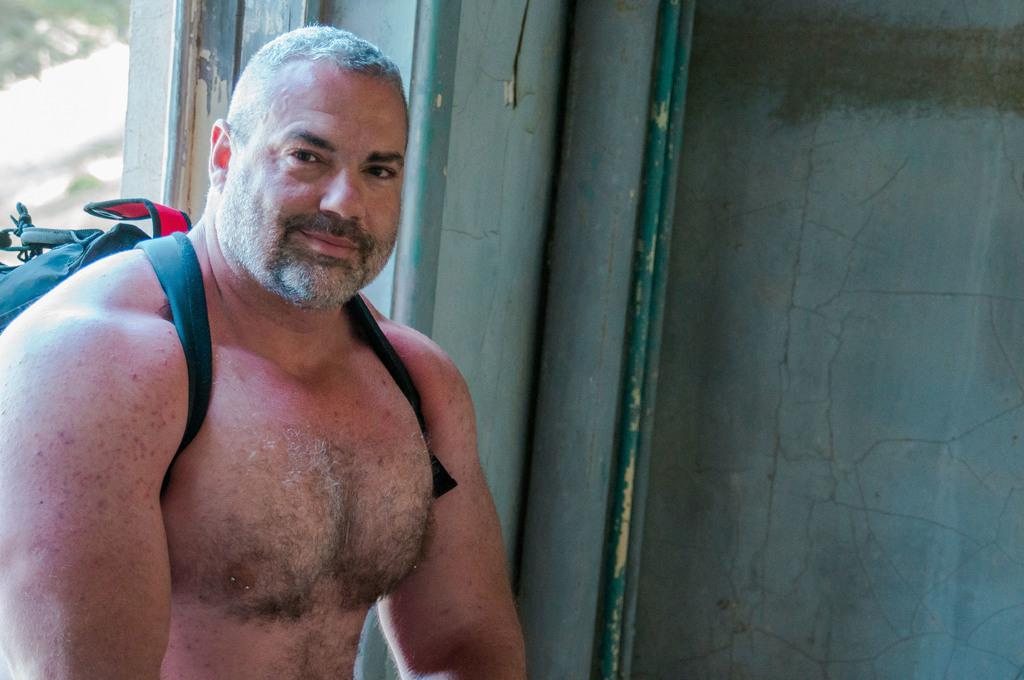Who or what is on the left side of the image? There is a person on the left side of the image. What can be seen in the background of the image? There is a wall in the background of the image. What type of toothpaste is the person using in the image? There is no toothpaste present in the image. What animal can be seen interacting with the person in the image? There is no animal present in the image. 